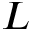Convert formula to latex. <formula><loc_0><loc_0><loc_500><loc_500>L</formula> 